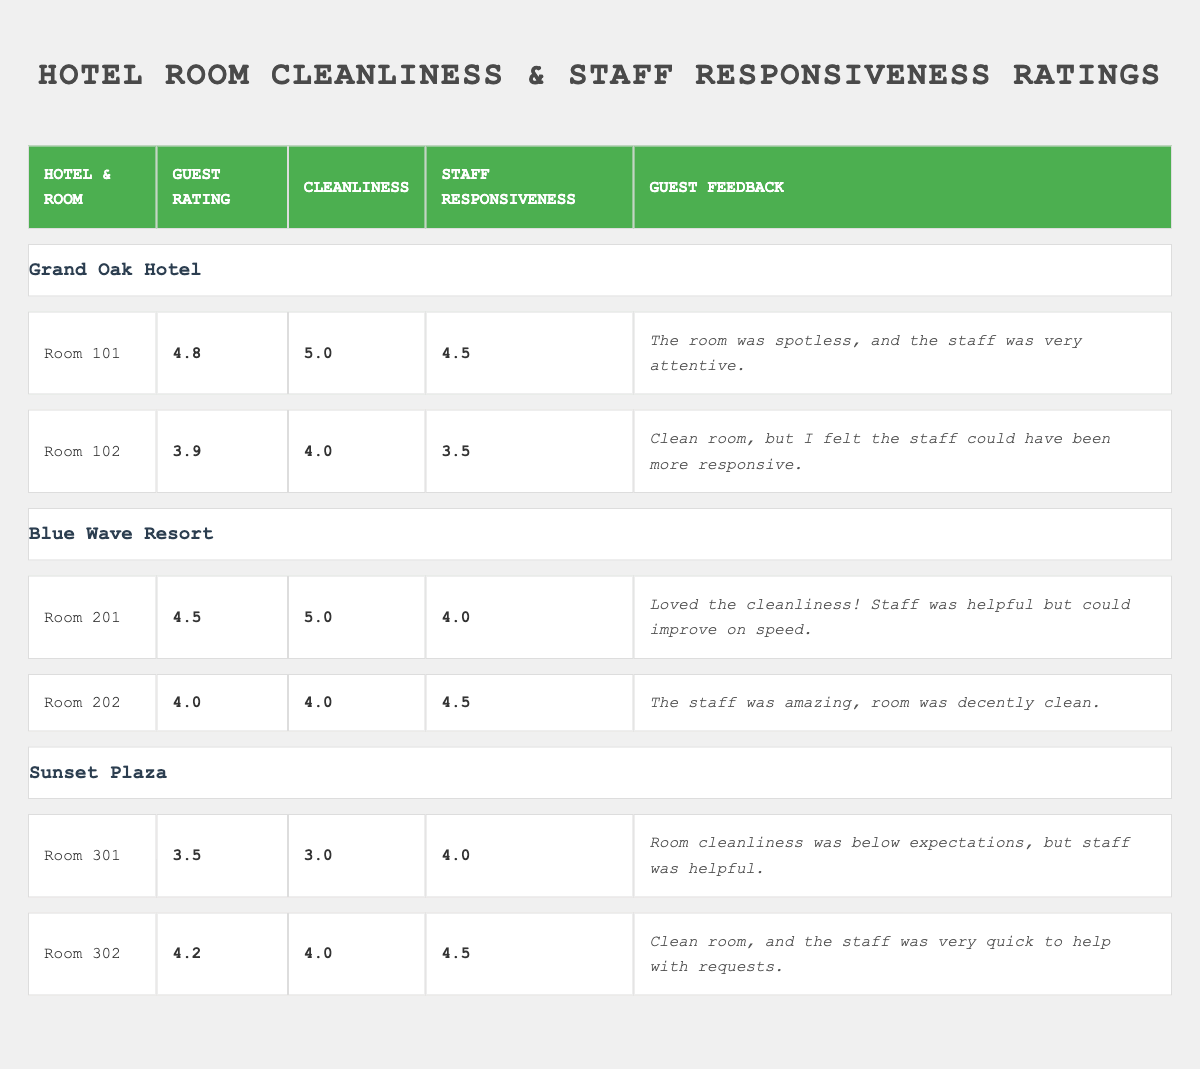What is the guest rating for room 101 in the Grand Oak Hotel? The guest rating for room 101 is provided in the table under the "Guest Rating" column for the Grand Oak Hotel section, which shows a rating of 4.8.
Answer: 4.8 Which hotel received the lowest cleanliness rating? Looking through the cleanliness ratings in the table, Sunset Plaza has room 301 with a cleanliness rating of 3.0, which is the lowest among all rooms.
Answer: Sunset Plaza What is the average guest rating for Blue Wave Resort? The guest ratings for Blue Wave Resort are 4.5 (Room 201) and 4.0 (Room 202). Adding these ratings gives us 4.5 + 4.0 = 8.5. There are 2 rooms, so the average is 8.5 / 2 = 4.25.
Answer: 4.25 Did any room in Sunset Plaza have a cleanliness rating of 4 or higher? In the Sunset Plaza section, room 302 has a cleanliness rating of 4.0, meeting the criteria of being 4 or higher, while room 301 has a rating of 3.0.
Answer: Yes Which room had the highest guest rating, and what was that rating? Examining all rooms, room 101 in the Grand Oak Hotel has the highest guest rating of 4.8.
Answer: Room 101, 4.8 How does the staff responsiveness rating for room 102 in the Grand Oak Hotel compare to room 202 in the Blue Wave Resort? Room 102 has a staff responsiveness rating of 3.5, while room 202 has a rating of 4.5. The difference is 4.5 - 3.5 = 1.0; hence room 202 is rated higher than room 102.
Answer: Room 202 is higher by 1.0 What is the total average cleanliness rating across all rooms? Adding up all the cleanliness ratings (5.0 + 4.0 + 5.0 + 4.0 + 3.0 + 4.0) gives 25.0. There are 6 rooms, so dividing gives us 25.0 / 6 ≈ 4.17.
Answer: 4.17 Does the Grand Oak Hotel have a room with a guest rating below 4.0? Room 102 in the Grand Oak Hotel has a guest rating of 3.9, which is below 4.0, confirming that there is indeed such a room.
Answer: Yes Which hotel has the highest average staff responsiveness rating? The staff responsiveness ratings are as follows: Grand Oak Hotel: (4.5 + 3.5) / 2 = 4.0, Blue Wave Resort: (4.0 + 4.5) / 2 = 4.25, Sunset Plaza: (4.0 + 4.5) / 2 = 4.25. The highest average is 4.25 from both Blue Wave Resort and Sunset Plaza.
Answer: Blue Wave Resort and Sunset Plaza (4.25) How many rooms had ratings of 4.0 or above for both cleanliness and staff responsiveness? Examining each room: Room 101 (5.0, 4.5), Room 201 (5.0, 4.0), Room 202 (4.0, 4.5), Room 302 (4.0, 4.5) all have both ratings at 4.0 or above. Room 102 and Room 301 fail to meet this requirement. Therefore, there are 4 qualifying rooms.
Answer: 4 rooms 